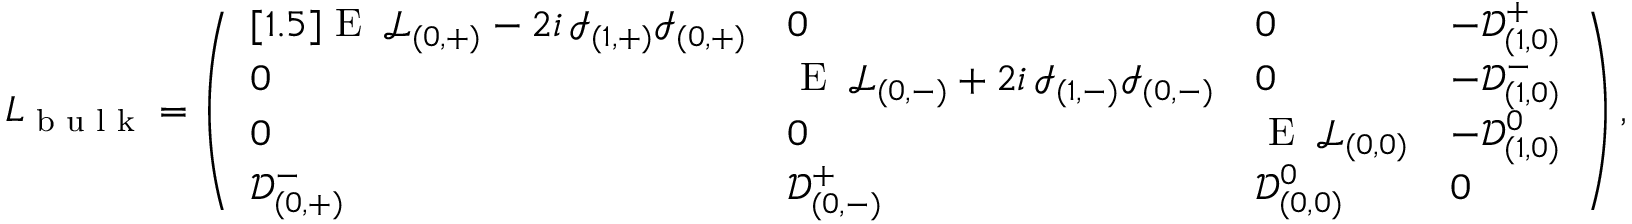Convert formula to latex. <formula><loc_0><loc_0><loc_500><loc_500>L _ { b u l k } = \left ( \begin{array} { l l l l } { [ 1 . 5 ] E \, \mathcal { L } _ { ( 0 , + ) } - 2 i \, \mathcal { I } _ { ( 1 , + ) } \mathcal { I } _ { ( 0 , + ) } } & { 0 } & { 0 } & { - \mathcal { D } _ { ( 1 , 0 ) } ^ { + } } \\ { 0 } & { E \, \mathcal { L } _ { ( 0 , - ) } + 2 i \, \mathcal { I } _ { ( 1 , - ) } \mathcal { I } _ { ( 0 , - ) } } & { 0 } & { - \mathcal { D } _ { ( 1 , 0 ) } ^ { - } } \\ { 0 } & { 0 } & { E \, \mathcal { L } _ { ( 0 , 0 ) } } & { - \mathcal { D } _ { ( 1 , 0 ) } ^ { 0 } } \\ { \mathcal { D } _ { ( 0 , + ) } ^ { - } } & { \mathcal { D } _ { ( 0 , - ) } ^ { + } } & { \mathcal { D } _ { ( 0 , 0 ) } ^ { 0 } } & { 0 } \end{array} \right ) ,</formula> 